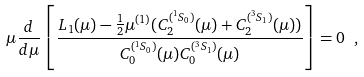<formula> <loc_0><loc_0><loc_500><loc_500>\mu \frac { d } { d \mu } \left [ \frac { L _ { 1 } ( \mu ) - \frac { 1 } { 2 } \mu ^ { ( 1 ) } ( C _ { 2 } ^ { ( ^ { 1 } S _ { 0 } ) } ( \mu ) + C _ { 2 } ^ { ( ^ { 3 } S _ { 1 } ) } ( \mu ) ) } { C _ { 0 } ^ { ( ^ { 1 } S _ { 0 } ) } ( \mu ) C _ { 0 } ^ { ( ^ { 3 } S _ { 1 } ) } ( \mu ) } \right ] = 0 \ ,</formula> 